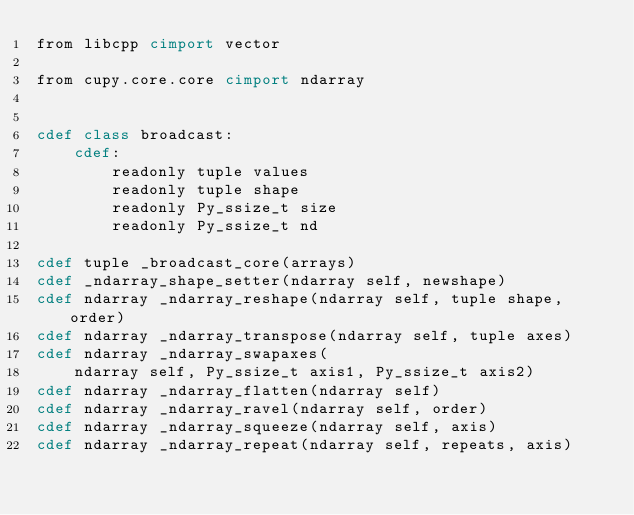<code> <loc_0><loc_0><loc_500><loc_500><_Cython_>from libcpp cimport vector

from cupy.core.core cimport ndarray


cdef class broadcast:
    cdef:
        readonly tuple values
        readonly tuple shape
        readonly Py_ssize_t size
        readonly Py_ssize_t nd

cdef tuple _broadcast_core(arrays)
cdef _ndarray_shape_setter(ndarray self, newshape)
cdef ndarray _ndarray_reshape(ndarray self, tuple shape, order)
cdef ndarray _ndarray_transpose(ndarray self, tuple axes)
cdef ndarray _ndarray_swapaxes(
    ndarray self, Py_ssize_t axis1, Py_ssize_t axis2)
cdef ndarray _ndarray_flatten(ndarray self)
cdef ndarray _ndarray_ravel(ndarray self, order)
cdef ndarray _ndarray_squeeze(ndarray self, axis)
cdef ndarray _ndarray_repeat(ndarray self, repeats, axis)
</code> 